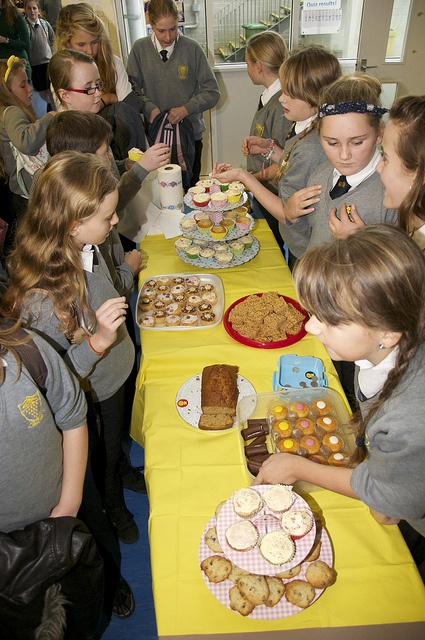Describe the objects in this image and their specific colors. I can see dining table in maroon, khaki, lightgray, and tan tones, people in maroon, gray, and darkgray tones, people in maroon, black, gray, and tan tones, cake in maroon, ivory, olive, and tan tones, and people in maroon and gray tones in this image. 